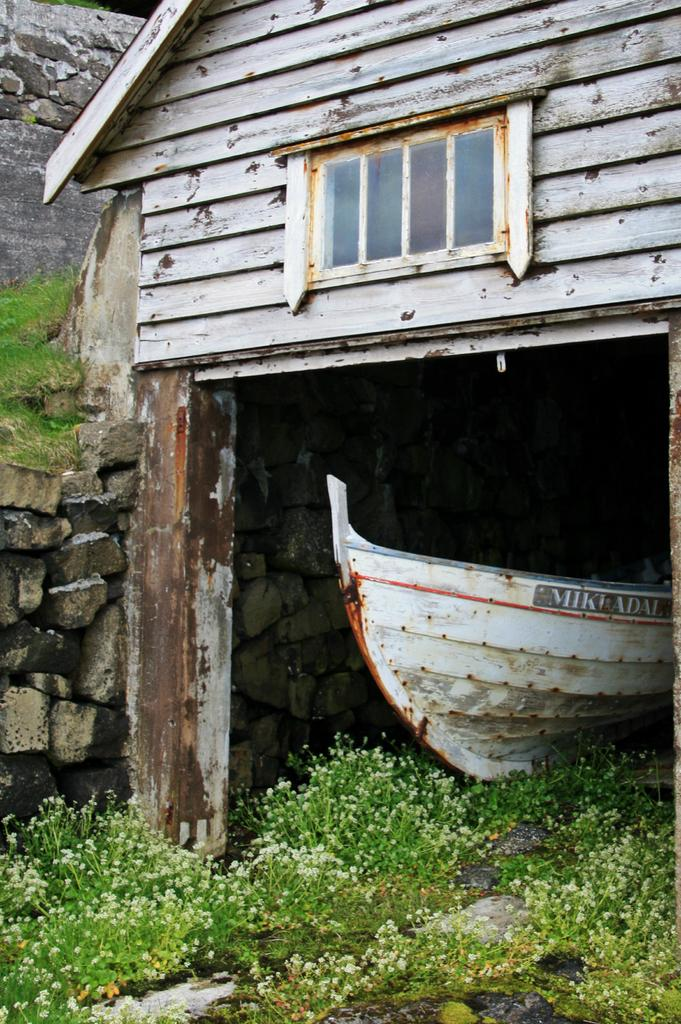What type of house is in the center of the image? There is a wooden house in the center of the image. What can be seen on the wooden house? There is a window and a wall visible on the wooden house. What else is present in the image besides the wooden house? There is a boat and grass visible in the image. Can you describe any other objects in the image? There are a few other objects in the image, but their specific details are not mentioned in the provided facts. What type of behavior can be observed in the scale in the image? There is no scale present in the image, so it is not possible to observe any behavior related to a scale. 